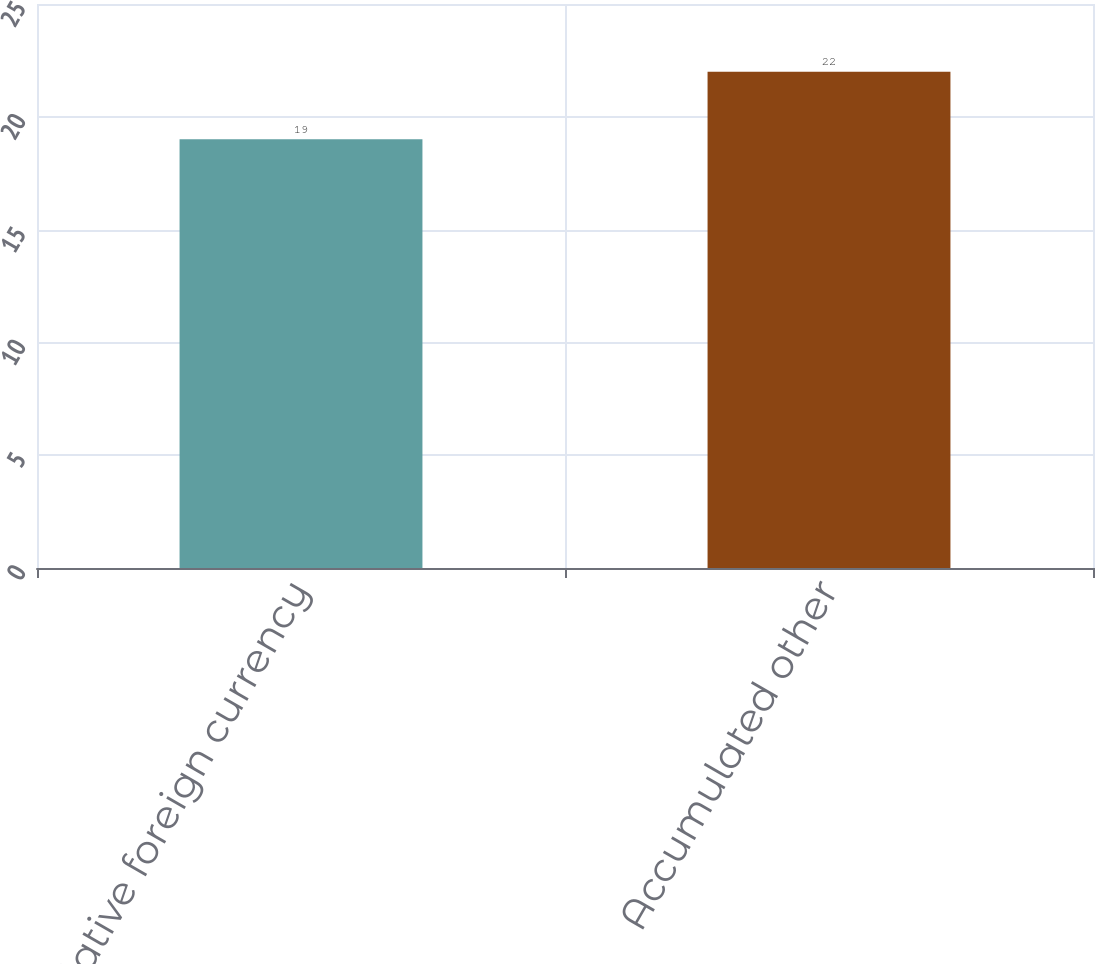<chart> <loc_0><loc_0><loc_500><loc_500><bar_chart><fcel>Cumulative foreign currency<fcel>Accumulated other<nl><fcel>19<fcel>22<nl></chart> 